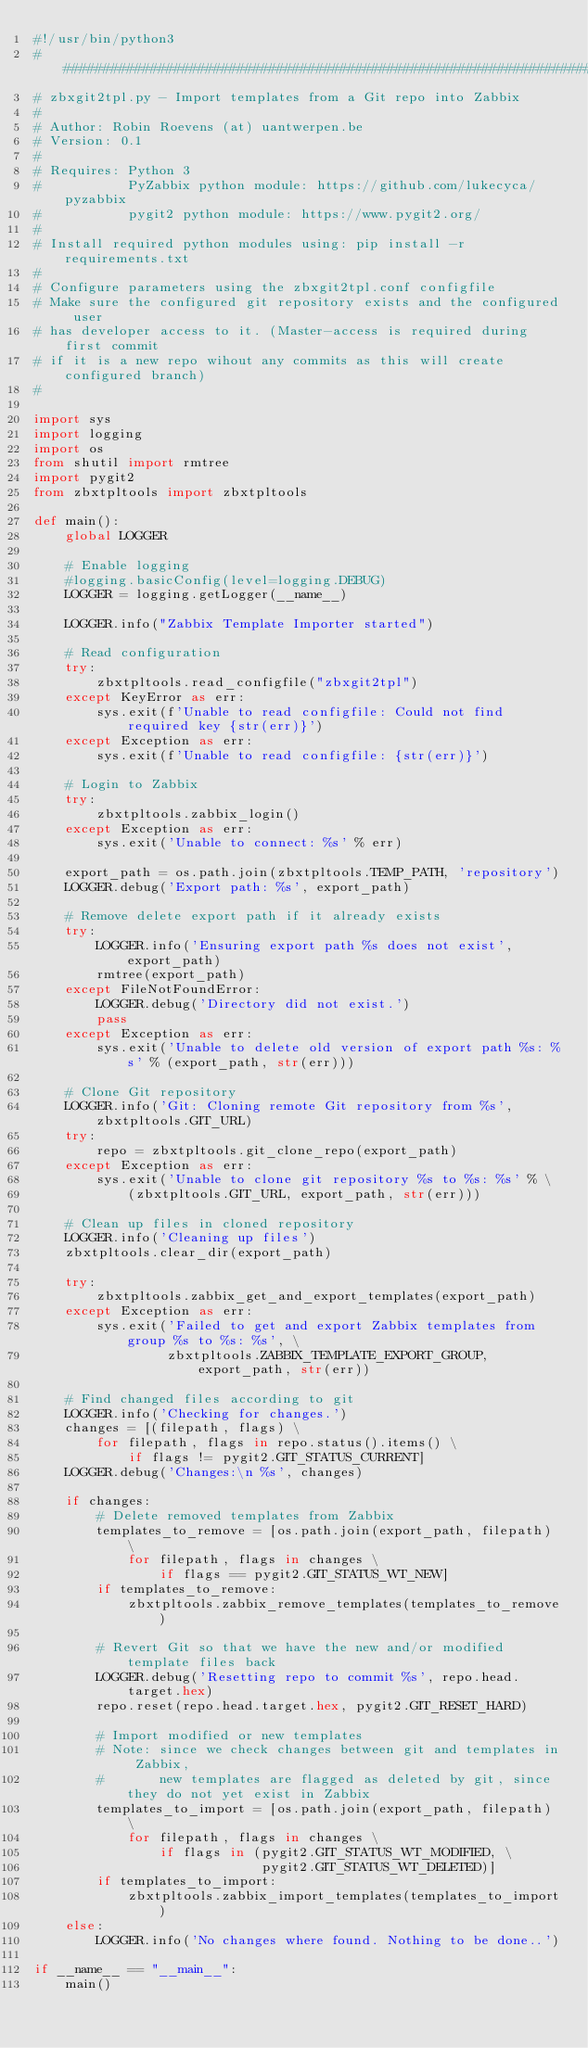<code> <loc_0><loc_0><loc_500><loc_500><_Python_>#!/usr/bin/python3
#############################################################################
# zbxgit2tpl.py - Import templates from a Git repo into Zabbix
#
# Author: Robin Roevens (at) uantwerpen.be
# Version: 0.1
#
# Requires: Python 3
#           PyZabbix python module: https://github.com/lukecyca/pyzabbix
#           pygit2 python module: https://www.pygit2.org/
#
# Install required python modules using: pip install -r requirements.txt
#
# Configure parameters using the zbxgit2tpl.conf configfile
# Make sure the configured git repository exists and the configured user
# has developer access to it. (Master-access is required during first commit
# if it is a new repo wihout any commits as this will create configured branch)
#

import sys
import logging
import os
from shutil import rmtree
import pygit2
from zbxtpltools import zbxtpltools

def main():
    global LOGGER

    # Enable logging
    #logging.basicConfig(level=logging.DEBUG)
    LOGGER = logging.getLogger(__name__)

    LOGGER.info("Zabbix Template Importer started")

    # Read configuration
    try:
        zbxtpltools.read_configfile("zbxgit2tpl")
    except KeyError as err:
        sys.exit(f'Unable to read configfile: Could not find required key {str(err)}')
    except Exception as err:
        sys.exit(f'Unable to read configfile: {str(err)}')

    # Login to Zabbix
    try:
        zbxtpltools.zabbix_login()
    except Exception as err:
        sys.exit('Unable to connect: %s' % err)

    export_path = os.path.join(zbxtpltools.TEMP_PATH, 'repository')
    LOGGER.debug('Export path: %s', export_path)

    # Remove delete export path if it already exists
    try:
        LOGGER.info('Ensuring export path %s does not exist', export_path)
        rmtree(export_path)
    except FileNotFoundError:
        LOGGER.debug('Directory did not exist.')
        pass
    except Exception as err:
        sys.exit('Unable to delete old version of export path %s: %s' % (export_path, str(err)))

    # Clone Git repository
    LOGGER.info('Git: Cloning remote Git repository from %s', zbxtpltools.GIT_URL)
    try:
        repo = zbxtpltools.git_clone_repo(export_path)
    except Exception as err:
        sys.exit('Unable to clone git repository %s to %s: %s' % \
            (zbxtpltools.GIT_URL, export_path, str(err)))

    # Clean up files in cloned repository
    LOGGER.info('Cleaning up files')
    zbxtpltools.clear_dir(export_path)

    try:
        zbxtpltools.zabbix_get_and_export_templates(export_path)
    except Exception as err:
        sys.exit('Failed to get and export Zabbix templates from group %s to %s: %s', \
                 zbxtpltools.ZABBIX_TEMPLATE_EXPORT_GROUP, export_path, str(err))

    # Find changed files according to git
    LOGGER.info('Checking for changes.')
    changes = [(filepath, flags) \
        for filepath, flags in repo.status().items() \
            if flags != pygit2.GIT_STATUS_CURRENT]
    LOGGER.debug('Changes:\n %s', changes)

    if changes:
        # Delete removed templates from Zabbix
        templates_to_remove = [os.path.join(export_path, filepath) \
            for filepath, flags in changes \
                if flags == pygit2.GIT_STATUS_WT_NEW]
        if templates_to_remove:
            zbxtpltools.zabbix_remove_templates(templates_to_remove)

        # Revert Git so that we have the new and/or modified template files back
        LOGGER.debug('Resetting repo to commit %s', repo.head.target.hex)
        repo.reset(repo.head.target.hex, pygit2.GIT_RESET_HARD)

        # Import modified or new templates
        # Note: since we check changes between git and templates in Zabbix,
        #       new templates are flagged as deleted by git, since they do not yet exist in Zabbix
        templates_to_import = [os.path.join(export_path, filepath) \
            for filepath, flags in changes \
                if flags in (pygit2.GIT_STATUS_WT_MODIFIED, \
                             pygit2.GIT_STATUS_WT_DELETED)]
        if templates_to_import:
            zbxtpltools.zabbix_import_templates(templates_to_import)
    else:
        LOGGER.info('No changes where found. Nothing to be done..')

if __name__ == "__main__":
    main()
</code> 